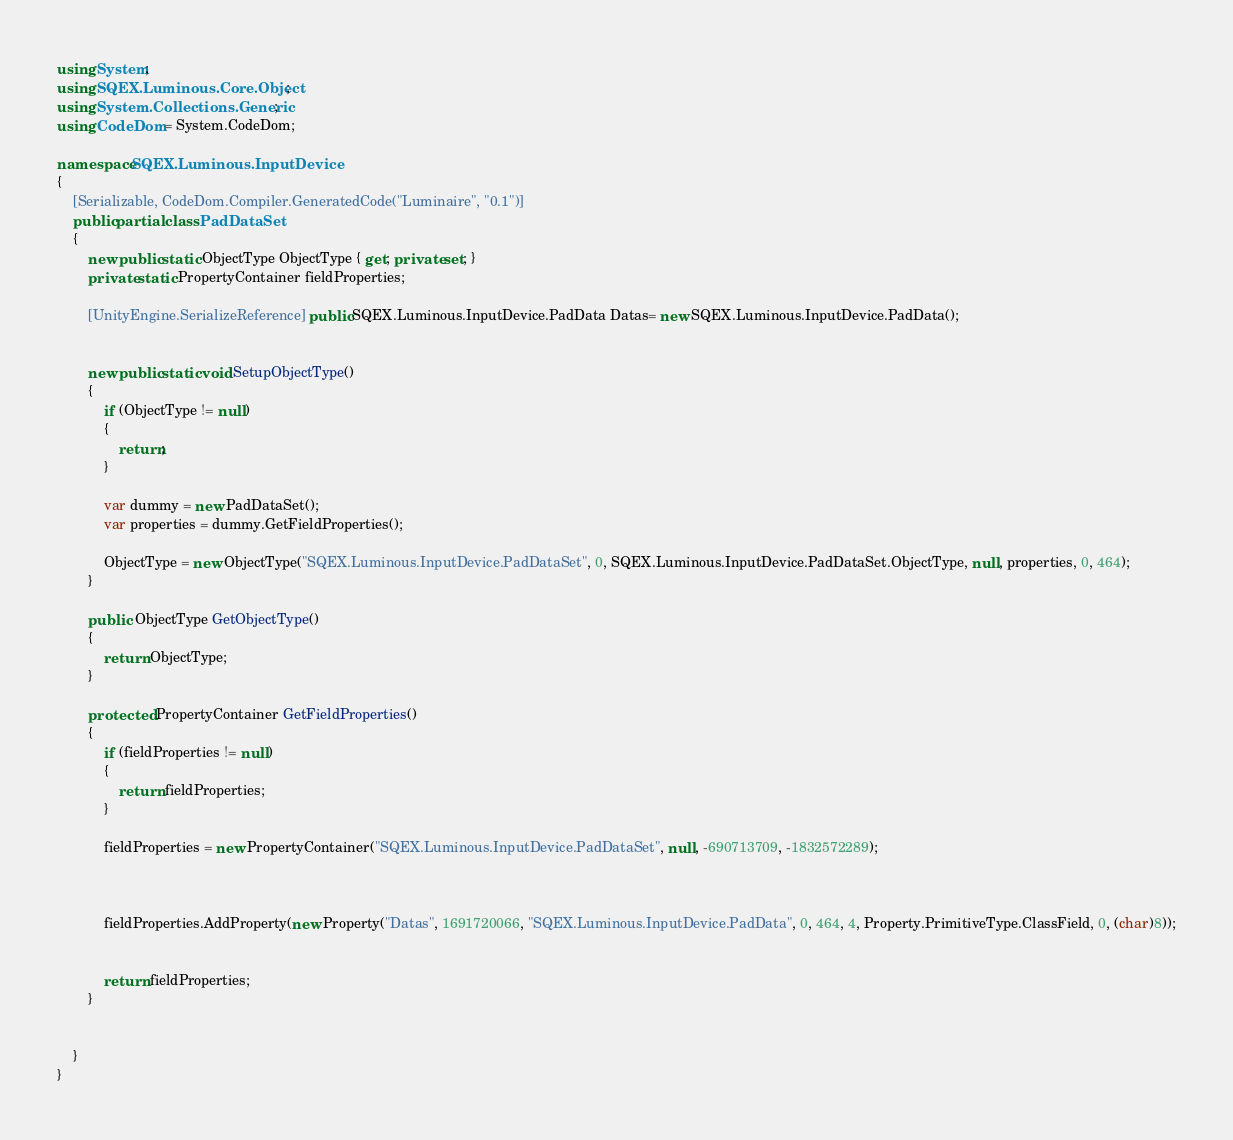<code> <loc_0><loc_0><loc_500><loc_500><_C#_>using System;
using SQEX.Luminous.Core.Object;
using System.Collections.Generic;
using CodeDom = System.CodeDom;

namespace SQEX.Luminous.InputDevice
{
    [Serializable, CodeDom.Compiler.GeneratedCode("Luminaire", "0.1")]
    public partial class PadDataSet
    {
        new public static ObjectType ObjectType { get; private set; }
        private static PropertyContainer fieldProperties;
		
		[UnityEngine.SerializeReference] public SQEX.Luminous.InputDevice.PadData Datas= new SQEX.Luminous.InputDevice.PadData();
		
        
        new public static void SetupObjectType()
        {
            if (ObjectType != null)
            {
                return;
            }

            var dummy = new PadDataSet();
            var properties = dummy.GetFieldProperties();

            ObjectType = new ObjectType("SQEX.Luminous.InputDevice.PadDataSet", 0, SQEX.Luminous.InputDevice.PadDataSet.ObjectType, null, properties, 0, 464);
        }
		
        public  ObjectType GetObjectType()
        {
            return ObjectType;
        }

        protected  PropertyContainer GetFieldProperties()
        {
            if (fieldProperties != null)
            {
                return fieldProperties;
            }

            fieldProperties = new PropertyContainer("SQEX.Luminous.InputDevice.PadDataSet", null, -690713709, -1832572289);
            
			
			
			fieldProperties.AddProperty(new Property("Datas", 1691720066, "SQEX.Luminous.InputDevice.PadData", 0, 464, 4, Property.PrimitiveType.ClassField, 0, (char)8));
			
			
			return fieldProperties;
        }

		
    }
}</code> 